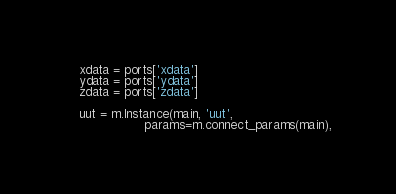Convert code to text. <code><loc_0><loc_0><loc_500><loc_500><_Python_>    xdata = ports['xdata']
    ydata = ports['ydata']
    zdata = ports['zdata']

    uut = m.Instance(main, 'uut',
                     params=m.connect_params(main),</code> 